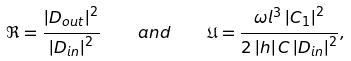<formula> <loc_0><loc_0><loc_500><loc_500>\Re = \frac { \left | D _ { o u t } \right | ^ { 2 } } { \left | D _ { i n } \right | ^ { 2 } } \quad { a n d } \quad \mathfrak { U } = \frac { \omega l ^ { 3 } \left | C _ { 1 } \right | ^ { 2 } } { 2 \left | h \right | C \left | D _ { i n } \right | ^ { 2 } } ,</formula> 